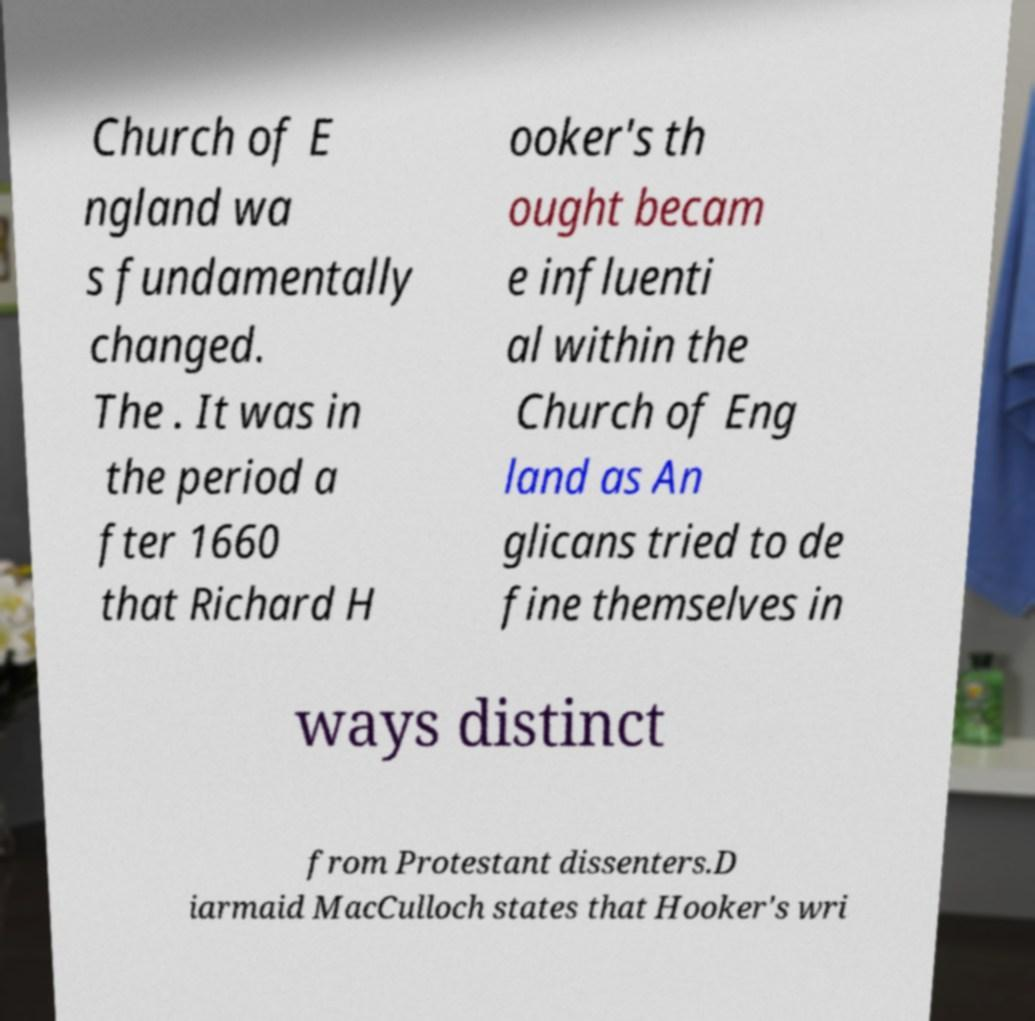Can you read and provide the text displayed in the image?This photo seems to have some interesting text. Can you extract and type it out for me? Church of E ngland wa s fundamentally changed. The . It was in the period a fter 1660 that Richard H ooker's th ought becam e influenti al within the Church of Eng land as An glicans tried to de fine themselves in ways distinct from Protestant dissenters.D iarmaid MacCulloch states that Hooker's wri 